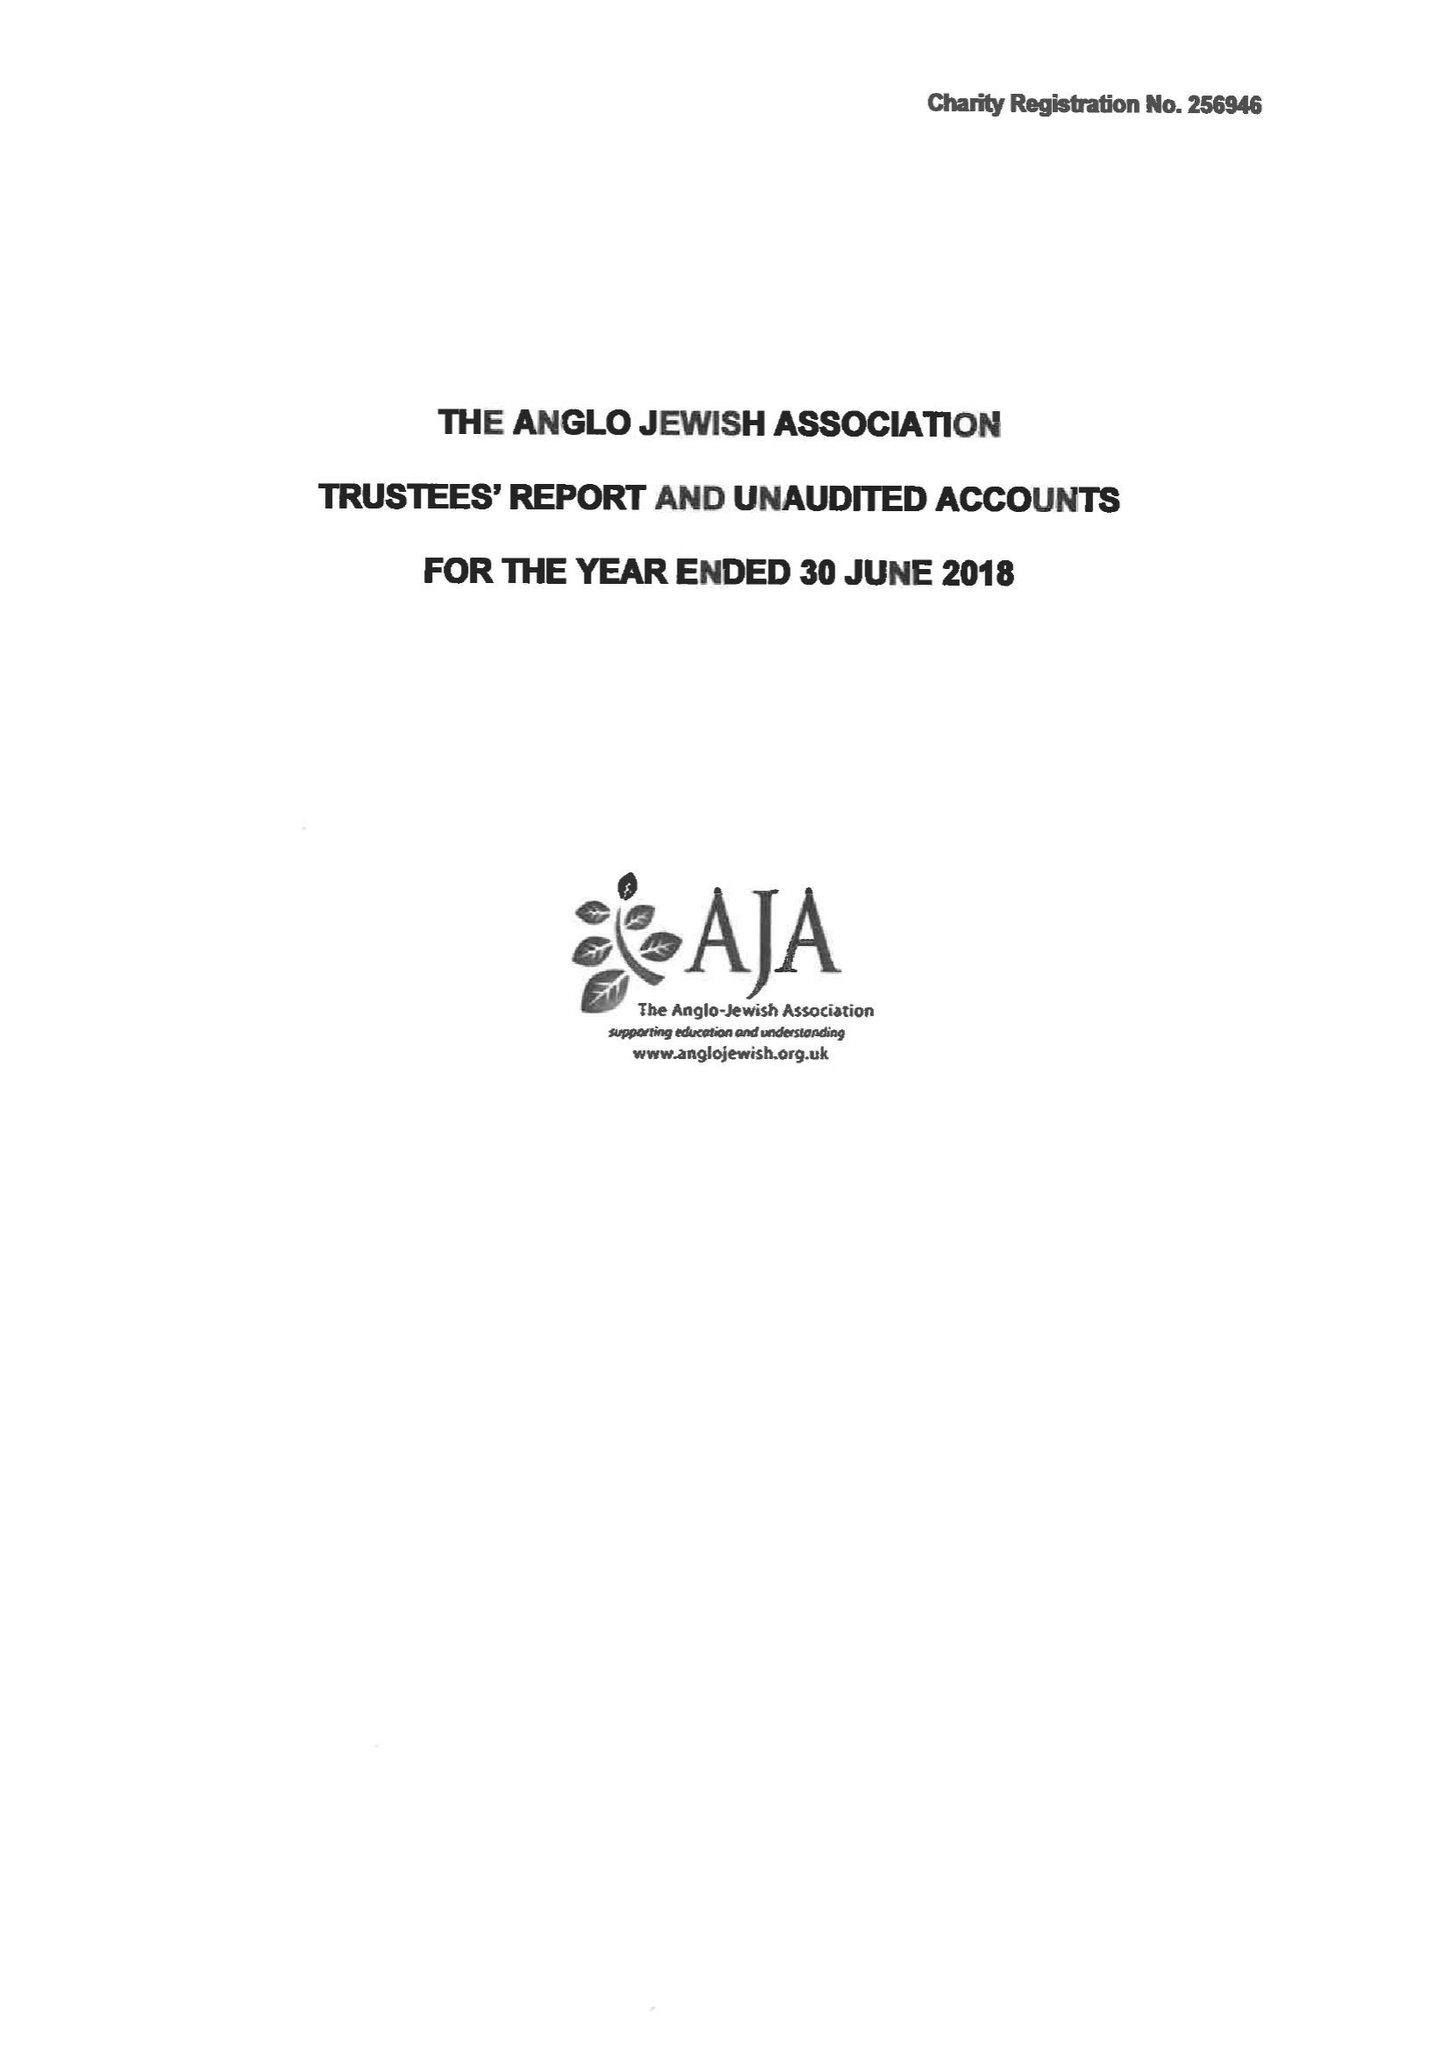What is the value for the address__street_line?
Answer the question using a single word or phrase. 75 MAYGROVE ROAD 